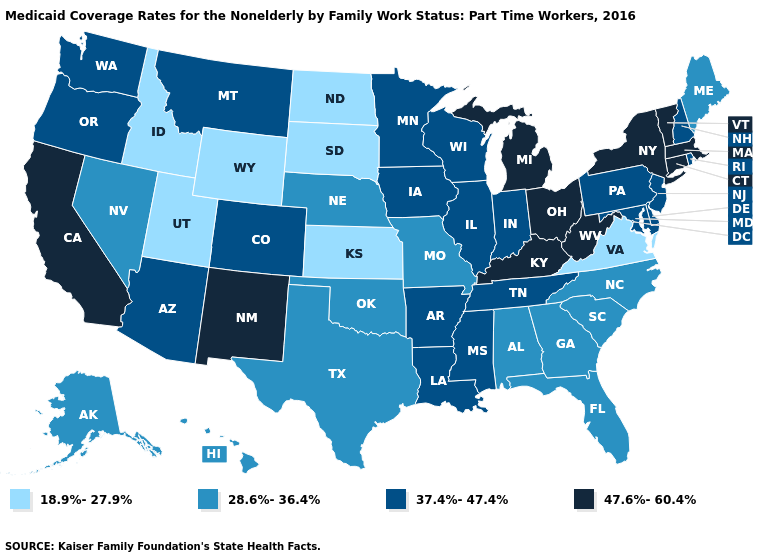Does the map have missing data?
Answer briefly. No. Among the states that border Tennessee , which have the highest value?
Answer briefly. Kentucky. Does Idaho have the lowest value in the USA?
Give a very brief answer. Yes. Does North Dakota have a lower value than South Dakota?
Write a very short answer. No. Does Louisiana have a higher value than Alabama?
Short answer required. Yes. How many symbols are there in the legend?
Answer briefly. 4. What is the lowest value in the USA?
Give a very brief answer. 18.9%-27.9%. How many symbols are there in the legend?
Concise answer only. 4. Does the first symbol in the legend represent the smallest category?
Answer briefly. Yes. Which states have the lowest value in the USA?
Keep it brief. Idaho, Kansas, North Dakota, South Dakota, Utah, Virginia, Wyoming. Does Oregon have the same value as Arkansas?
Concise answer only. Yes. What is the value of Washington?
Write a very short answer. 37.4%-47.4%. What is the value of Idaho?
Keep it brief. 18.9%-27.9%. Does South Dakota have the lowest value in the MidWest?
Short answer required. Yes. Name the states that have a value in the range 28.6%-36.4%?
Short answer required. Alabama, Alaska, Florida, Georgia, Hawaii, Maine, Missouri, Nebraska, Nevada, North Carolina, Oklahoma, South Carolina, Texas. 